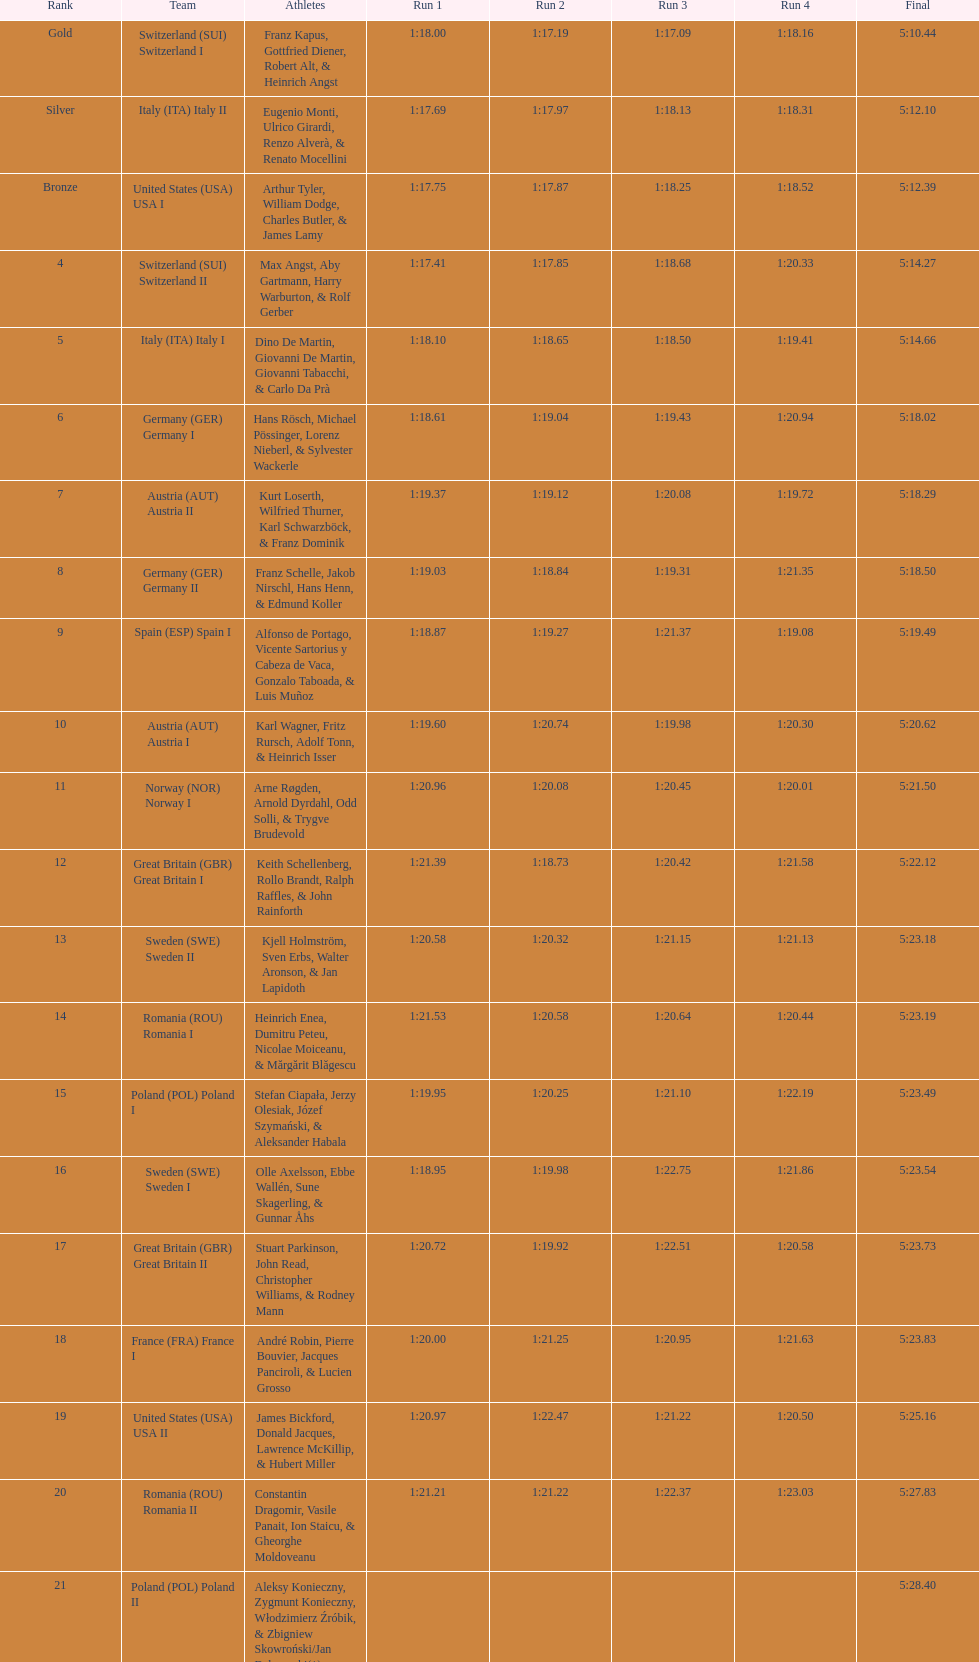What is the total amount of runs? 4. 